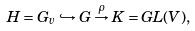Convert formula to latex. <formula><loc_0><loc_0><loc_500><loc_500>H = G _ { v } \hookrightarrow G \stackrel { \rho } { \rightarrow } K = G L ( V ) ,</formula> 